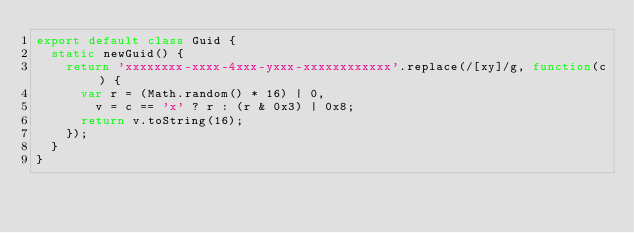<code> <loc_0><loc_0><loc_500><loc_500><_TypeScript_>export default class Guid {
  static newGuid() {
    return 'xxxxxxxx-xxxx-4xxx-yxxx-xxxxxxxxxxxx'.replace(/[xy]/g, function(c) {
      var r = (Math.random() * 16) | 0,
        v = c == 'x' ? r : (r & 0x3) | 0x8;
      return v.toString(16);
    });
  }
}
</code> 